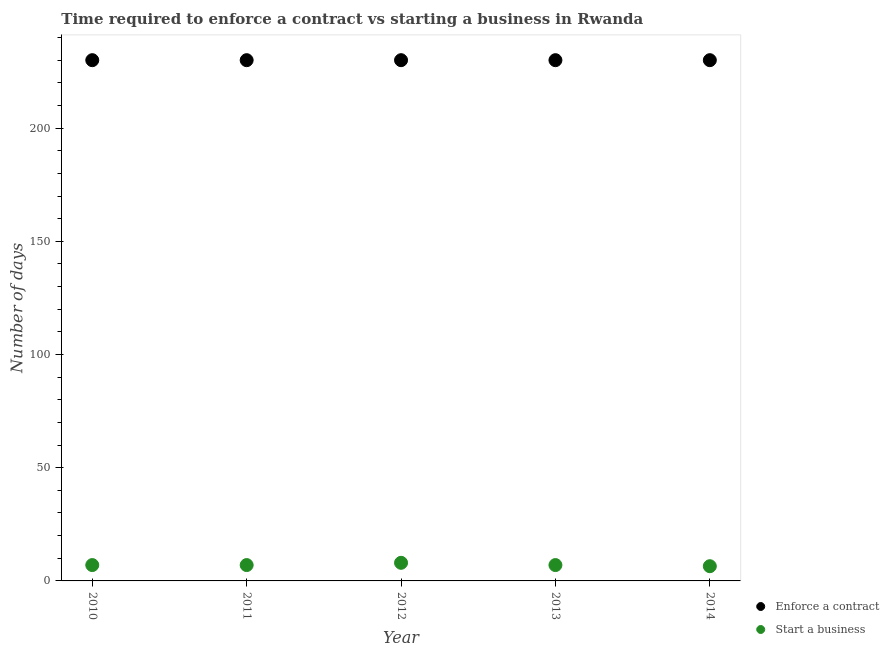How many different coloured dotlines are there?
Your response must be concise. 2. What is the number of days to enforece a contract in 2012?
Your answer should be compact. 230. Across all years, what is the maximum number of days to enforece a contract?
Keep it short and to the point. 230. What is the total number of days to enforece a contract in the graph?
Your answer should be compact. 1150. What is the difference between the number of days to start a business in 2010 and the number of days to enforece a contract in 2013?
Your answer should be compact. -223. In the year 2011, what is the difference between the number of days to enforece a contract and number of days to start a business?
Offer a terse response. 223. In how many years, is the number of days to enforece a contract greater than 150 days?
Provide a short and direct response. 5. What is the ratio of the number of days to enforece a contract in 2011 to that in 2013?
Offer a terse response. 1. What is the difference between the highest and the lowest number of days to start a business?
Offer a terse response. 1.5. In how many years, is the number of days to enforece a contract greater than the average number of days to enforece a contract taken over all years?
Your answer should be compact. 0. Is the sum of the number of days to enforece a contract in 2011 and 2014 greater than the maximum number of days to start a business across all years?
Your answer should be very brief. Yes. Does the number of days to start a business monotonically increase over the years?
Your answer should be compact. No. Is the number of days to start a business strictly greater than the number of days to enforece a contract over the years?
Make the answer very short. No. Are the values on the major ticks of Y-axis written in scientific E-notation?
Make the answer very short. No. How are the legend labels stacked?
Ensure brevity in your answer.  Vertical. What is the title of the graph?
Provide a succinct answer. Time required to enforce a contract vs starting a business in Rwanda. What is the label or title of the X-axis?
Your answer should be compact. Year. What is the label or title of the Y-axis?
Give a very brief answer. Number of days. What is the Number of days in Enforce a contract in 2010?
Your answer should be very brief. 230. What is the Number of days in Enforce a contract in 2011?
Offer a terse response. 230. What is the Number of days of Enforce a contract in 2012?
Give a very brief answer. 230. What is the Number of days in Enforce a contract in 2013?
Provide a short and direct response. 230. What is the Number of days of Start a business in 2013?
Your answer should be very brief. 7. What is the Number of days in Enforce a contract in 2014?
Your response must be concise. 230. Across all years, what is the maximum Number of days of Enforce a contract?
Offer a very short reply. 230. Across all years, what is the minimum Number of days in Enforce a contract?
Provide a succinct answer. 230. What is the total Number of days of Enforce a contract in the graph?
Give a very brief answer. 1150. What is the total Number of days in Start a business in the graph?
Keep it short and to the point. 35.5. What is the difference between the Number of days in Start a business in 2010 and that in 2011?
Keep it short and to the point. 0. What is the difference between the Number of days in Enforce a contract in 2010 and that in 2012?
Provide a succinct answer. 0. What is the difference between the Number of days in Start a business in 2010 and that in 2012?
Ensure brevity in your answer.  -1. What is the difference between the Number of days of Enforce a contract in 2010 and that in 2013?
Provide a short and direct response. 0. What is the difference between the Number of days of Start a business in 2010 and that in 2013?
Offer a very short reply. 0. What is the difference between the Number of days in Start a business in 2010 and that in 2014?
Offer a terse response. 0.5. What is the difference between the Number of days in Start a business in 2011 and that in 2012?
Your answer should be very brief. -1. What is the difference between the Number of days of Start a business in 2011 and that in 2014?
Your response must be concise. 0.5. What is the difference between the Number of days of Enforce a contract in 2013 and that in 2014?
Provide a short and direct response. 0. What is the difference between the Number of days of Enforce a contract in 2010 and the Number of days of Start a business in 2011?
Your response must be concise. 223. What is the difference between the Number of days in Enforce a contract in 2010 and the Number of days in Start a business in 2012?
Provide a succinct answer. 222. What is the difference between the Number of days of Enforce a contract in 2010 and the Number of days of Start a business in 2013?
Your answer should be very brief. 223. What is the difference between the Number of days in Enforce a contract in 2010 and the Number of days in Start a business in 2014?
Offer a terse response. 223.5. What is the difference between the Number of days of Enforce a contract in 2011 and the Number of days of Start a business in 2012?
Your answer should be very brief. 222. What is the difference between the Number of days of Enforce a contract in 2011 and the Number of days of Start a business in 2013?
Your answer should be very brief. 223. What is the difference between the Number of days in Enforce a contract in 2011 and the Number of days in Start a business in 2014?
Provide a succinct answer. 223.5. What is the difference between the Number of days in Enforce a contract in 2012 and the Number of days in Start a business in 2013?
Your answer should be very brief. 223. What is the difference between the Number of days in Enforce a contract in 2012 and the Number of days in Start a business in 2014?
Provide a short and direct response. 223.5. What is the difference between the Number of days of Enforce a contract in 2013 and the Number of days of Start a business in 2014?
Give a very brief answer. 223.5. What is the average Number of days in Enforce a contract per year?
Your answer should be compact. 230. In the year 2010, what is the difference between the Number of days of Enforce a contract and Number of days of Start a business?
Make the answer very short. 223. In the year 2011, what is the difference between the Number of days of Enforce a contract and Number of days of Start a business?
Give a very brief answer. 223. In the year 2012, what is the difference between the Number of days of Enforce a contract and Number of days of Start a business?
Keep it short and to the point. 222. In the year 2013, what is the difference between the Number of days of Enforce a contract and Number of days of Start a business?
Offer a terse response. 223. In the year 2014, what is the difference between the Number of days of Enforce a contract and Number of days of Start a business?
Keep it short and to the point. 223.5. What is the ratio of the Number of days in Start a business in 2010 to that in 2013?
Your answer should be compact. 1. What is the ratio of the Number of days of Enforce a contract in 2011 to that in 2013?
Provide a succinct answer. 1. What is the ratio of the Number of days in Start a business in 2011 to that in 2013?
Offer a terse response. 1. What is the ratio of the Number of days of Enforce a contract in 2011 to that in 2014?
Provide a short and direct response. 1. What is the ratio of the Number of days in Enforce a contract in 2012 to that in 2013?
Ensure brevity in your answer.  1. What is the ratio of the Number of days in Start a business in 2012 to that in 2014?
Offer a very short reply. 1.23. What is the difference between the highest and the lowest Number of days in Enforce a contract?
Ensure brevity in your answer.  0. What is the difference between the highest and the lowest Number of days of Start a business?
Your response must be concise. 1.5. 